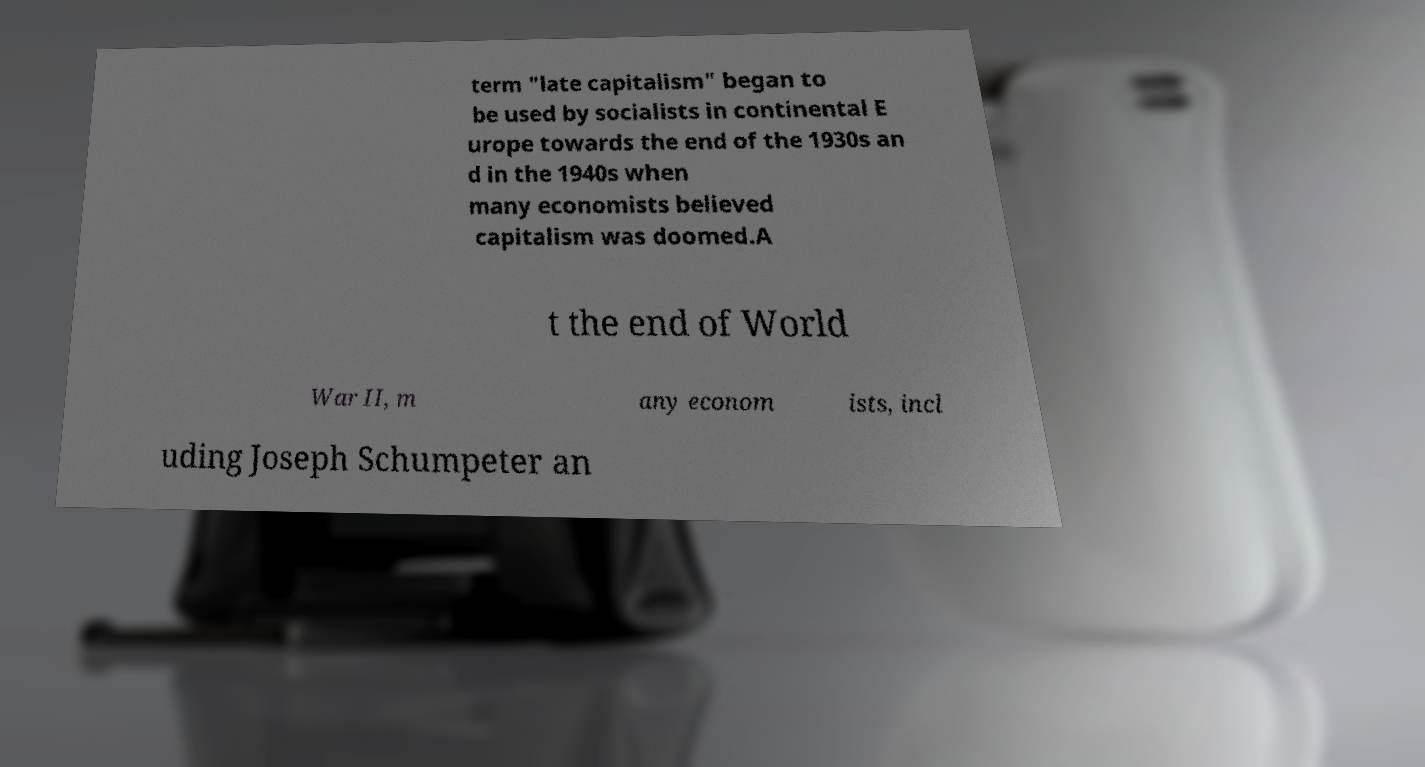Can you accurately transcribe the text from the provided image for me? term "late capitalism" began to be used by socialists in continental E urope towards the end of the 1930s an d in the 1940s when many economists believed capitalism was doomed.A t the end of World War II, m any econom ists, incl uding Joseph Schumpeter an 